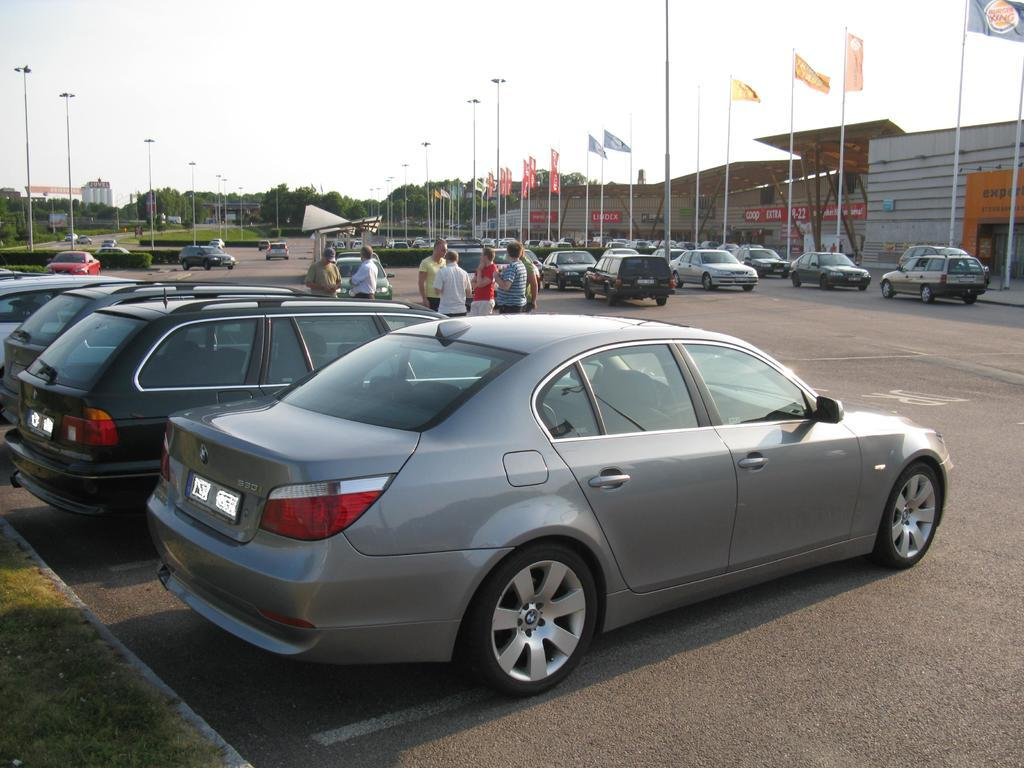What types of vehicles can be seen in the image? There are vehicles in the image, but the specific types are not mentioned. What are the people in the image doing? There is a group of people standing on the road in the image. What type of vegetation is present in the image? Bushes, trees, and buildings are present in the image. What other objects can be seen in the image? Flags and poles are visible in the image. What is visible in the background of the image? The sky is visible in the background of the image. Where is the potato located in the image? There is no potato present in the image. What color is the scarf worn by the person standing on the road? There is no person wearing a scarf in the image. 